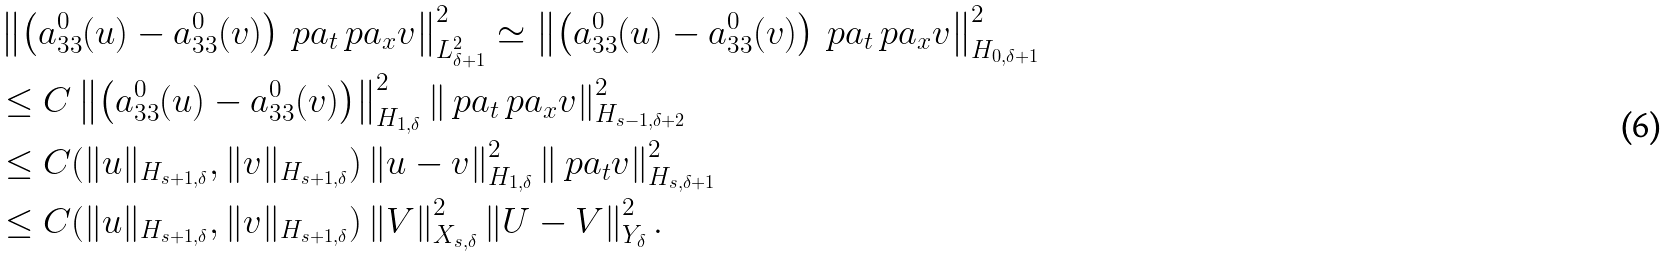<formula> <loc_0><loc_0><loc_500><loc_500>& \left \| \left ( { a } _ { 3 3 } ^ { 0 } ( u ) - { a } _ { 3 3 } ^ { 0 } ( v ) \right ) \ p a _ { t } \ p a _ { x } v \right \| _ { L _ { \delta + 1 } ^ { 2 } } ^ { 2 } \simeq \left \| \left ( { a } _ { 3 3 } ^ { 0 } ( u ) - { a } _ { 3 3 } ^ { 0 } ( v ) \right ) \ p a _ { t } \ p a _ { x } v \right \| _ { H _ { 0 , \delta + 1 } } ^ { 2 } \\ & \leq C \left \| \left ( { a } _ { 3 3 } ^ { 0 } ( u ) - { a } _ { 3 3 } ^ { 0 } ( v ) \right ) \right \| _ { H _ { 1 , \delta } } ^ { 2 } \left \| \ p a _ { t } \ p a _ { x } v \right \| _ { H _ { s - 1 , \delta + 2 } } ^ { 2 } \\ & \leq C ( \| u \| _ { H _ { s + 1 , \delta } } , \| v \| _ { H _ { s + 1 , \delta } } ) \left \| u - v \right \| _ { H _ { 1 , \delta } } ^ { 2 } \left \| \ p a _ { t } v \right \| _ { H _ { s , \delta + 1 } } ^ { 2 } \\ & \leq C ( \| u \| _ { H _ { s + 1 , \delta } } , \| v \| _ { H _ { s + 1 , \delta } } ) \left \| V \right \| _ { X _ { s , \delta } } ^ { 2 } \left \| U - V \right \| ^ { 2 } _ { Y _ { \delta } } .</formula> 